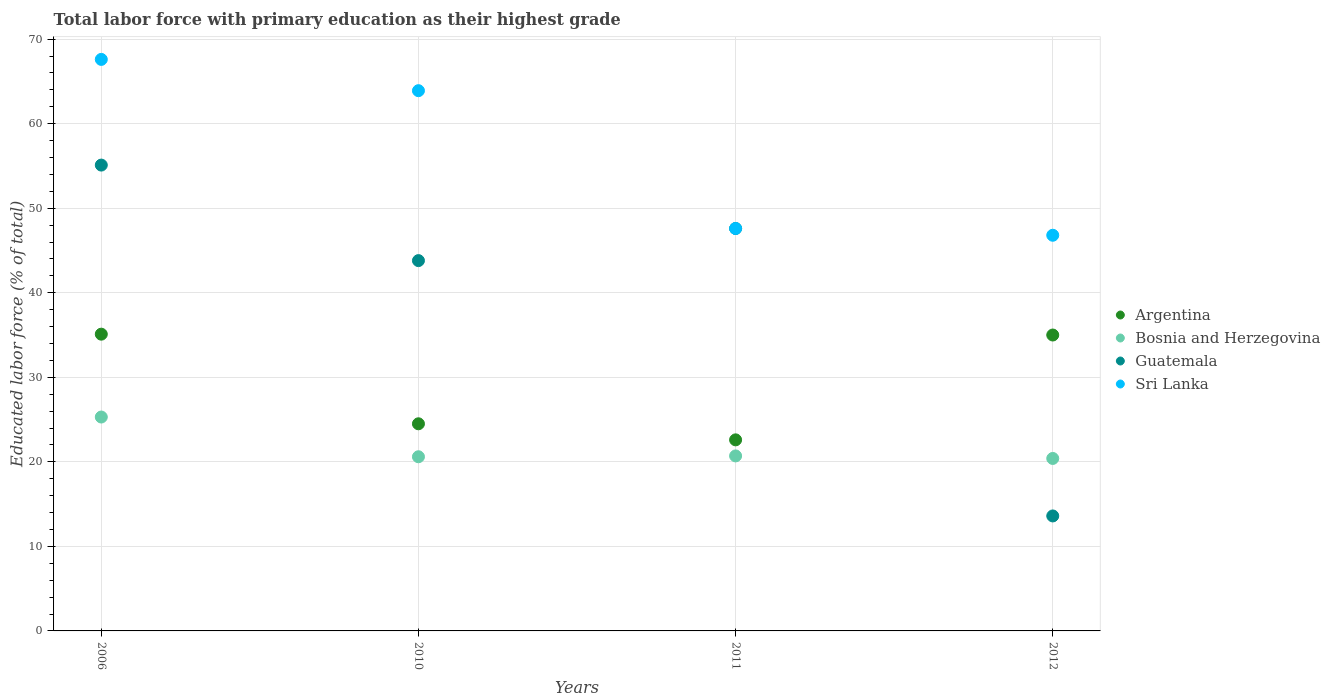How many different coloured dotlines are there?
Ensure brevity in your answer.  4. Is the number of dotlines equal to the number of legend labels?
Offer a very short reply. Yes. What is the percentage of total labor force with primary education in Guatemala in 2012?
Give a very brief answer. 13.6. Across all years, what is the maximum percentage of total labor force with primary education in Sri Lanka?
Your answer should be very brief. 67.6. Across all years, what is the minimum percentage of total labor force with primary education in Sri Lanka?
Your answer should be compact. 46.8. In which year was the percentage of total labor force with primary education in Guatemala minimum?
Your response must be concise. 2012. What is the total percentage of total labor force with primary education in Bosnia and Herzegovina in the graph?
Provide a succinct answer. 87. What is the difference between the percentage of total labor force with primary education in Sri Lanka in 2011 and that in 2012?
Keep it short and to the point. 0.8. What is the difference between the percentage of total labor force with primary education in Bosnia and Herzegovina in 2006 and the percentage of total labor force with primary education in Guatemala in 2011?
Make the answer very short. -22.3. What is the average percentage of total labor force with primary education in Sri Lanka per year?
Offer a very short reply. 56.47. In the year 2012, what is the difference between the percentage of total labor force with primary education in Argentina and percentage of total labor force with primary education in Guatemala?
Offer a very short reply. 21.4. In how many years, is the percentage of total labor force with primary education in Sri Lanka greater than 44 %?
Your answer should be compact. 4. What is the ratio of the percentage of total labor force with primary education in Bosnia and Herzegovina in 2010 to that in 2012?
Your answer should be compact. 1.01. Is the percentage of total labor force with primary education in Guatemala in 2006 less than that in 2012?
Offer a very short reply. No. Is the difference between the percentage of total labor force with primary education in Argentina in 2010 and 2012 greater than the difference between the percentage of total labor force with primary education in Guatemala in 2010 and 2012?
Make the answer very short. No. What is the difference between the highest and the second highest percentage of total labor force with primary education in Sri Lanka?
Provide a short and direct response. 3.7. What is the difference between the highest and the lowest percentage of total labor force with primary education in Sri Lanka?
Offer a very short reply. 20.8. In how many years, is the percentage of total labor force with primary education in Bosnia and Herzegovina greater than the average percentage of total labor force with primary education in Bosnia and Herzegovina taken over all years?
Your answer should be very brief. 1. Is it the case that in every year, the sum of the percentage of total labor force with primary education in Sri Lanka and percentage of total labor force with primary education in Guatemala  is greater than the sum of percentage of total labor force with primary education in Bosnia and Herzegovina and percentage of total labor force with primary education in Argentina?
Offer a terse response. Yes. Is it the case that in every year, the sum of the percentage of total labor force with primary education in Argentina and percentage of total labor force with primary education in Sri Lanka  is greater than the percentage of total labor force with primary education in Guatemala?
Offer a terse response. Yes. Does the percentage of total labor force with primary education in Sri Lanka monotonically increase over the years?
Provide a short and direct response. No. Is the percentage of total labor force with primary education in Sri Lanka strictly greater than the percentage of total labor force with primary education in Bosnia and Herzegovina over the years?
Your response must be concise. Yes. Is the percentage of total labor force with primary education in Guatemala strictly less than the percentage of total labor force with primary education in Argentina over the years?
Ensure brevity in your answer.  No. How many dotlines are there?
Offer a terse response. 4. How many years are there in the graph?
Offer a very short reply. 4. Does the graph contain any zero values?
Keep it short and to the point. No. Where does the legend appear in the graph?
Give a very brief answer. Center right. How are the legend labels stacked?
Your answer should be very brief. Vertical. What is the title of the graph?
Provide a succinct answer. Total labor force with primary education as their highest grade. What is the label or title of the Y-axis?
Offer a very short reply. Educated labor force (% of total). What is the Educated labor force (% of total) in Argentina in 2006?
Give a very brief answer. 35.1. What is the Educated labor force (% of total) of Bosnia and Herzegovina in 2006?
Keep it short and to the point. 25.3. What is the Educated labor force (% of total) in Guatemala in 2006?
Keep it short and to the point. 55.1. What is the Educated labor force (% of total) of Sri Lanka in 2006?
Give a very brief answer. 67.6. What is the Educated labor force (% of total) in Argentina in 2010?
Keep it short and to the point. 24.5. What is the Educated labor force (% of total) in Bosnia and Herzegovina in 2010?
Your answer should be very brief. 20.6. What is the Educated labor force (% of total) of Guatemala in 2010?
Make the answer very short. 43.8. What is the Educated labor force (% of total) of Sri Lanka in 2010?
Make the answer very short. 63.9. What is the Educated labor force (% of total) in Argentina in 2011?
Ensure brevity in your answer.  22.6. What is the Educated labor force (% of total) of Bosnia and Herzegovina in 2011?
Offer a terse response. 20.7. What is the Educated labor force (% of total) of Guatemala in 2011?
Your answer should be very brief. 47.6. What is the Educated labor force (% of total) in Sri Lanka in 2011?
Provide a short and direct response. 47.6. What is the Educated labor force (% of total) of Bosnia and Herzegovina in 2012?
Your answer should be compact. 20.4. What is the Educated labor force (% of total) in Guatemala in 2012?
Provide a short and direct response. 13.6. What is the Educated labor force (% of total) in Sri Lanka in 2012?
Your response must be concise. 46.8. Across all years, what is the maximum Educated labor force (% of total) in Argentina?
Ensure brevity in your answer.  35.1. Across all years, what is the maximum Educated labor force (% of total) of Bosnia and Herzegovina?
Provide a succinct answer. 25.3. Across all years, what is the maximum Educated labor force (% of total) of Guatemala?
Provide a short and direct response. 55.1. Across all years, what is the maximum Educated labor force (% of total) in Sri Lanka?
Ensure brevity in your answer.  67.6. Across all years, what is the minimum Educated labor force (% of total) in Argentina?
Ensure brevity in your answer.  22.6. Across all years, what is the minimum Educated labor force (% of total) in Bosnia and Herzegovina?
Offer a very short reply. 20.4. Across all years, what is the minimum Educated labor force (% of total) of Guatemala?
Make the answer very short. 13.6. Across all years, what is the minimum Educated labor force (% of total) of Sri Lanka?
Offer a very short reply. 46.8. What is the total Educated labor force (% of total) of Argentina in the graph?
Give a very brief answer. 117.2. What is the total Educated labor force (% of total) in Bosnia and Herzegovina in the graph?
Keep it short and to the point. 87. What is the total Educated labor force (% of total) of Guatemala in the graph?
Offer a very short reply. 160.1. What is the total Educated labor force (% of total) in Sri Lanka in the graph?
Ensure brevity in your answer.  225.9. What is the difference between the Educated labor force (% of total) of Guatemala in 2006 and that in 2010?
Provide a succinct answer. 11.3. What is the difference between the Educated labor force (% of total) of Argentina in 2006 and that in 2011?
Provide a succinct answer. 12.5. What is the difference between the Educated labor force (% of total) of Sri Lanka in 2006 and that in 2011?
Give a very brief answer. 20. What is the difference between the Educated labor force (% of total) in Guatemala in 2006 and that in 2012?
Keep it short and to the point. 41.5. What is the difference between the Educated labor force (% of total) of Sri Lanka in 2006 and that in 2012?
Provide a succinct answer. 20.8. What is the difference between the Educated labor force (% of total) in Guatemala in 2010 and that in 2011?
Give a very brief answer. -3.8. What is the difference between the Educated labor force (% of total) in Sri Lanka in 2010 and that in 2011?
Make the answer very short. 16.3. What is the difference between the Educated labor force (% of total) in Argentina in 2010 and that in 2012?
Your response must be concise. -10.5. What is the difference between the Educated labor force (% of total) of Bosnia and Herzegovina in 2010 and that in 2012?
Give a very brief answer. 0.2. What is the difference between the Educated labor force (% of total) in Guatemala in 2010 and that in 2012?
Your response must be concise. 30.2. What is the difference between the Educated labor force (% of total) of Bosnia and Herzegovina in 2011 and that in 2012?
Give a very brief answer. 0.3. What is the difference between the Educated labor force (% of total) in Sri Lanka in 2011 and that in 2012?
Make the answer very short. 0.8. What is the difference between the Educated labor force (% of total) in Argentina in 2006 and the Educated labor force (% of total) in Bosnia and Herzegovina in 2010?
Offer a terse response. 14.5. What is the difference between the Educated labor force (% of total) in Argentina in 2006 and the Educated labor force (% of total) in Guatemala in 2010?
Your answer should be very brief. -8.7. What is the difference between the Educated labor force (% of total) in Argentina in 2006 and the Educated labor force (% of total) in Sri Lanka in 2010?
Offer a very short reply. -28.8. What is the difference between the Educated labor force (% of total) in Bosnia and Herzegovina in 2006 and the Educated labor force (% of total) in Guatemala in 2010?
Offer a terse response. -18.5. What is the difference between the Educated labor force (% of total) in Bosnia and Herzegovina in 2006 and the Educated labor force (% of total) in Sri Lanka in 2010?
Make the answer very short. -38.6. What is the difference between the Educated labor force (% of total) of Argentina in 2006 and the Educated labor force (% of total) of Sri Lanka in 2011?
Make the answer very short. -12.5. What is the difference between the Educated labor force (% of total) of Bosnia and Herzegovina in 2006 and the Educated labor force (% of total) of Guatemala in 2011?
Make the answer very short. -22.3. What is the difference between the Educated labor force (% of total) in Bosnia and Herzegovina in 2006 and the Educated labor force (% of total) in Sri Lanka in 2011?
Your answer should be compact. -22.3. What is the difference between the Educated labor force (% of total) of Guatemala in 2006 and the Educated labor force (% of total) of Sri Lanka in 2011?
Keep it short and to the point. 7.5. What is the difference between the Educated labor force (% of total) in Argentina in 2006 and the Educated labor force (% of total) in Bosnia and Herzegovina in 2012?
Your answer should be compact. 14.7. What is the difference between the Educated labor force (% of total) in Argentina in 2006 and the Educated labor force (% of total) in Sri Lanka in 2012?
Provide a succinct answer. -11.7. What is the difference between the Educated labor force (% of total) of Bosnia and Herzegovina in 2006 and the Educated labor force (% of total) of Guatemala in 2012?
Ensure brevity in your answer.  11.7. What is the difference between the Educated labor force (% of total) in Bosnia and Herzegovina in 2006 and the Educated labor force (% of total) in Sri Lanka in 2012?
Offer a terse response. -21.5. What is the difference between the Educated labor force (% of total) of Guatemala in 2006 and the Educated labor force (% of total) of Sri Lanka in 2012?
Make the answer very short. 8.3. What is the difference between the Educated labor force (% of total) in Argentina in 2010 and the Educated labor force (% of total) in Bosnia and Herzegovina in 2011?
Make the answer very short. 3.8. What is the difference between the Educated labor force (% of total) in Argentina in 2010 and the Educated labor force (% of total) in Guatemala in 2011?
Offer a very short reply. -23.1. What is the difference between the Educated labor force (% of total) of Argentina in 2010 and the Educated labor force (% of total) of Sri Lanka in 2011?
Provide a succinct answer. -23.1. What is the difference between the Educated labor force (% of total) of Bosnia and Herzegovina in 2010 and the Educated labor force (% of total) of Guatemala in 2011?
Give a very brief answer. -27. What is the difference between the Educated labor force (% of total) in Guatemala in 2010 and the Educated labor force (% of total) in Sri Lanka in 2011?
Offer a very short reply. -3.8. What is the difference between the Educated labor force (% of total) in Argentina in 2010 and the Educated labor force (% of total) in Bosnia and Herzegovina in 2012?
Ensure brevity in your answer.  4.1. What is the difference between the Educated labor force (% of total) in Argentina in 2010 and the Educated labor force (% of total) in Guatemala in 2012?
Give a very brief answer. 10.9. What is the difference between the Educated labor force (% of total) of Argentina in 2010 and the Educated labor force (% of total) of Sri Lanka in 2012?
Your answer should be very brief. -22.3. What is the difference between the Educated labor force (% of total) of Bosnia and Herzegovina in 2010 and the Educated labor force (% of total) of Guatemala in 2012?
Keep it short and to the point. 7. What is the difference between the Educated labor force (% of total) of Bosnia and Herzegovina in 2010 and the Educated labor force (% of total) of Sri Lanka in 2012?
Your answer should be compact. -26.2. What is the difference between the Educated labor force (% of total) of Guatemala in 2010 and the Educated labor force (% of total) of Sri Lanka in 2012?
Keep it short and to the point. -3. What is the difference between the Educated labor force (% of total) of Argentina in 2011 and the Educated labor force (% of total) of Bosnia and Herzegovina in 2012?
Keep it short and to the point. 2.2. What is the difference between the Educated labor force (% of total) of Argentina in 2011 and the Educated labor force (% of total) of Guatemala in 2012?
Your response must be concise. 9. What is the difference between the Educated labor force (% of total) of Argentina in 2011 and the Educated labor force (% of total) of Sri Lanka in 2012?
Keep it short and to the point. -24.2. What is the difference between the Educated labor force (% of total) of Bosnia and Herzegovina in 2011 and the Educated labor force (% of total) of Guatemala in 2012?
Your answer should be compact. 7.1. What is the difference between the Educated labor force (% of total) of Bosnia and Herzegovina in 2011 and the Educated labor force (% of total) of Sri Lanka in 2012?
Offer a very short reply. -26.1. What is the average Educated labor force (% of total) in Argentina per year?
Your response must be concise. 29.3. What is the average Educated labor force (% of total) of Bosnia and Herzegovina per year?
Make the answer very short. 21.75. What is the average Educated labor force (% of total) in Guatemala per year?
Provide a succinct answer. 40.02. What is the average Educated labor force (% of total) in Sri Lanka per year?
Offer a very short reply. 56.48. In the year 2006, what is the difference between the Educated labor force (% of total) of Argentina and Educated labor force (% of total) of Guatemala?
Keep it short and to the point. -20. In the year 2006, what is the difference between the Educated labor force (% of total) of Argentina and Educated labor force (% of total) of Sri Lanka?
Ensure brevity in your answer.  -32.5. In the year 2006, what is the difference between the Educated labor force (% of total) in Bosnia and Herzegovina and Educated labor force (% of total) in Guatemala?
Ensure brevity in your answer.  -29.8. In the year 2006, what is the difference between the Educated labor force (% of total) in Bosnia and Herzegovina and Educated labor force (% of total) in Sri Lanka?
Your response must be concise. -42.3. In the year 2006, what is the difference between the Educated labor force (% of total) of Guatemala and Educated labor force (% of total) of Sri Lanka?
Offer a terse response. -12.5. In the year 2010, what is the difference between the Educated labor force (% of total) of Argentina and Educated labor force (% of total) of Bosnia and Herzegovina?
Keep it short and to the point. 3.9. In the year 2010, what is the difference between the Educated labor force (% of total) in Argentina and Educated labor force (% of total) in Guatemala?
Your response must be concise. -19.3. In the year 2010, what is the difference between the Educated labor force (% of total) of Argentina and Educated labor force (% of total) of Sri Lanka?
Give a very brief answer. -39.4. In the year 2010, what is the difference between the Educated labor force (% of total) in Bosnia and Herzegovina and Educated labor force (% of total) in Guatemala?
Your answer should be very brief. -23.2. In the year 2010, what is the difference between the Educated labor force (% of total) in Bosnia and Herzegovina and Educated labor force (% of total) in Sri Lanka?
Provide a short and direct response. -43.3. In the year 2010, what is the difference between the Educated labor force (% of total) in Guatemala and Educated labor force (% of total) in Sri Lanka?
Offer a very short reply. -20.1. In the year 2011, what is the difference between the Educated labor force (% of total) of Argentina and Educated labor force (% of total) of Bosnia and Herzegovina?
Provide a succinct answer. 1.9. In the year 2011, what is the difference between the Educated labor force (% of total) in Argentina and Educated labor force (% of total) in Guatemala?
Provide a short and direct response. -25. In the year 2011, what is the difference between the Educated labor force (% of total) in Argentina and Educated labor force (% of total) in Sri Lanka?
Make the answer very short. -25. In the year 2011, what is the difference between the Educated labor force (% of total) of Bosnia and Herzegovina and Educated labor force (% of total) of Guatemala?
Ensure brevity in your answer.  -26.9. In the year 2011, what is the difference between the Educated labor force (% of total) of Bosnia and Herzegovina and Educated labor force (% of total) of Sri Lanka?
Offer a very short reply. -26.9. In the year 2012, what is the difference between the Educated labor force (% of total) of Argentina and Educated labor force (% of total) of Bosnia and Herzegovina?
Your answer should be very brief. 14.6. In the year 2012, what is the difference between the Educated labor force (% of total) in Argentina and Educated labor force (% of total) in Guatemala?
Your answer should be very brief. 21.4. In the year 2012, what is the difference between the Educated labor force (% of total) in Bosnia and Herzegovina and Educated labor force (% of total) in Sri Lanka?
Provide a short and direct response. -26.4. In the year 2012, what is the difference between the Educated labor force (% of total) in Guatemala and Educated labor force (% of total) in Sri Lanka?
Give a very brief answer. -33.2. What is the ratio of the Educated labor force (% of total) in Argentina in 2006 to that in 2010?
Offer a terse response. 1.43. What is the ratio of the Educated labor force (% of total) in Bosnia and Herzegovina in 2006 to that in 2010?
Your response must be concise. 1.23. What is the ratio of the Educated labor force (% of total) in Guatemala in 2006 to that in 2010?
Provide a short and direct response. 1.26. What is the ratio of the Educated labor force (% of total) in Sri Lanka in 2006 to that in 2010?
Ensure brevity in your answer.  1.06. What is the ratio of the Educated labor force (% of total) in Argentina in 2006 to that in 2011?
Your answer should be compact. 1.55. What is the ratio of the Educated labor force (% of total) of Bosnia and Herzegovina in 2006 to that in 2011?
Make the answer very short. 1.22. What is the ratio of the Educated labor force (% of total) of Guatemala in 2006 to that in 2011?
Offer a terse response. 1.16. What is the ratio of the Educated labor force (% of total) of Sri Lanka in 2006 to that in 2011?
Ensure brevity in your answer.  1.42. What is the ratio of the Educated labor force (% of total) in Bosnia and Herzegovina in 2006 to that in 2012?
Your answer should be very brief. 1.24. What is the ratio of the Educated labor force (% of total) in Guatemala in 2006 to that in 2012?
Ensure brevity in your answer.  4.05. What is the ratio of the Educated labor force (% of total) of Sri Lanka in 2006 to that in 2012?
Keep it short and to the point. 1.44. What is the ratio of the Educated labor force (% of total) in Argentina in 2010 to that in 2011?
Offer a very short reply. 1.08. What is the ratio of the Educated labor force (% of total) in Guatemala in 2010 to that in 2011?
Provide a short and direct response. 0.92. What is the ratio of the Educated labor force (% of total) of Sri Lanka in 2010 to that in 2011?
Your answer should be compact. 1.34. What is the ratio of the Educated labor force (% of total) of Argentina in 2010 to that in 2012?
Your response must be concise. 0.7. What is the ratio of the Educated labor force (% of total) of Bosnia and Herzegovina in 2010 to that in 2012?
Give a very brief answer. 1.01. What is the ratio of the Educated labor force (% of total) of Guatemala in 2010 to that in 2012?
Give a very brief answer. 3.22. What is the ratio of the Educated labor force (% of total) of Sri Lanka in 2010 to that in 2012?
Keep it short and to the point. 1.37. What is the ratio of the Educated labor force (% of total) in Argentina in 2011 to that in 2012?
Offer a very short reply. 0.65. What is the ratio of the Educated labor force (% of total) in Bosnia and Herzegovina in 2011 to that in 2012?
Keep it short and to the point. 1.01. What is the ratio of the Educated labor force (% of total) of Guatemala in 2011 to that in 2012?
Keep it short and to the point. 3.5. What is the ratio of the Educated labor force (% of total) of Sri Lanka in 2011 to that in 2012?
Offer a very short reply. 1.02. What is the difference between the highest and the second highest Educated labor force (% of total) of Sri Lanka?
Give a very brief answer. 3.7. What is the difference between the highest and the lowest Educated labor force (% of total) of Guatemala?
Provide a short and direct response. 41.5. What is the difference between the highest and the lowest Educated labor force (% of total) of Sri Lanka?
Make the answer very short. 20.8. 